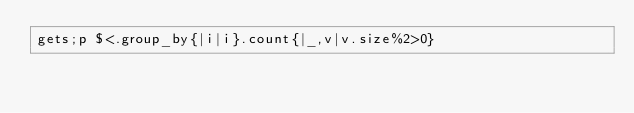Convert code to text. <code><loc_0><loc_0><loc_500><loc_500><_Ruby_>gets;p $<.group_by{|i|i}.count{|_,v|v.size%2>0}</code> 